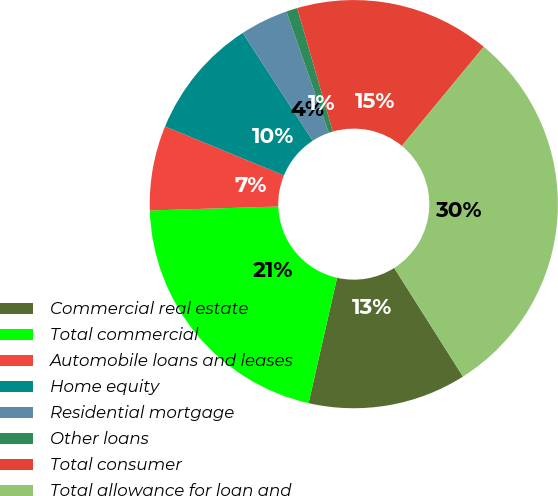Convert chart to OTSL. <chart><loc_0><loc_0><loc_500><loc_500><pie_chart><fcel>Commercial real estate<fcel>Total commercial<fcel>Automobile loans and leases<fcel>Home equity<fcel>Residential mortgage<fcel>Other loans<fcel>Total consumer<fcel>Total allowance for loan and<nl><fcel>12.54%<fcel>20.95%<fcel>6.71%<fcel>9.63%<fcel>3.8%<fcel>0.88%<fcel>15.46%<fcel>30.03%<nl></chart> 